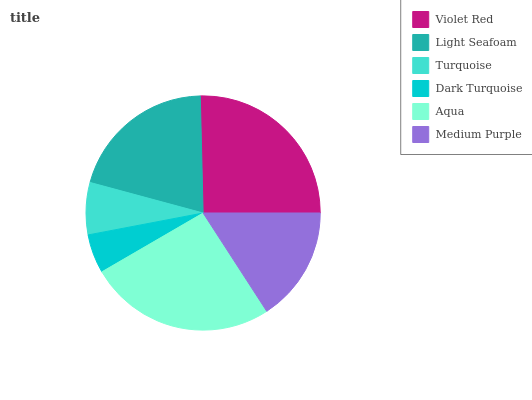Is Dark Turquoise the minimum?
Answer yes or no. Yes. Is Aqua the maximum?
Answer yes or no. Yes. Is Light Seafoam the minimum?
Answer yes or no. No. Is Light Seafoam the maximum?
Answer yes or no. No. Is Violet Red greater than Light Seafoam?
Answer yes or no. Yes. Is Light Seafoam less than Violet Red?
Answer yes or no. Yes. Is Light Seafoam greater than Violet Red?
Answer yes or no. No. Is Violet Red less than Light Seafoam?
Answer yes or no. No. Is Light Seafoam the high median?
Answer yes or no. Yes. Is Medium Purple the low median?
Answer yes or no. Yes. Is Aqua the high median?
Answer yes or no. No. Is Dark Turquoise the low median?
Answer yes or no. No. 